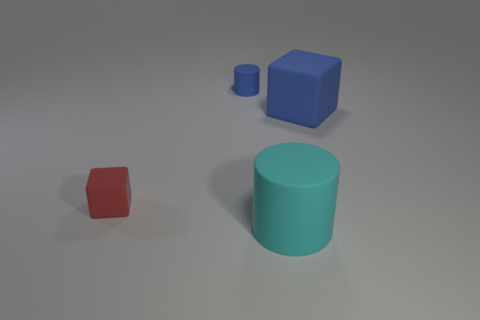Subtract all blue cubes. How many cubes are left? 1 Add 1 tiny blue metal cylinders. How many objects exist? 5 Subtract 2 cylinders. How many cylinders are left? 0 Add 1 cyan matte cylinders. How many cyan matte cylinders exist? 2 Subtract 0 gray cubes. How many objects are left? 4 Subtract all blue cylinders. Subtract all brown spheres. How many cylinders are left? 1 Subtract all yellow balls. How many blue cylinders are left? 1 Subtract all red rubber cubes. Subtract all tiny matte cylinders. How many objects are left? 2 Add 4 big rubber cylinders. How many big rubber cylinders are left? 5 